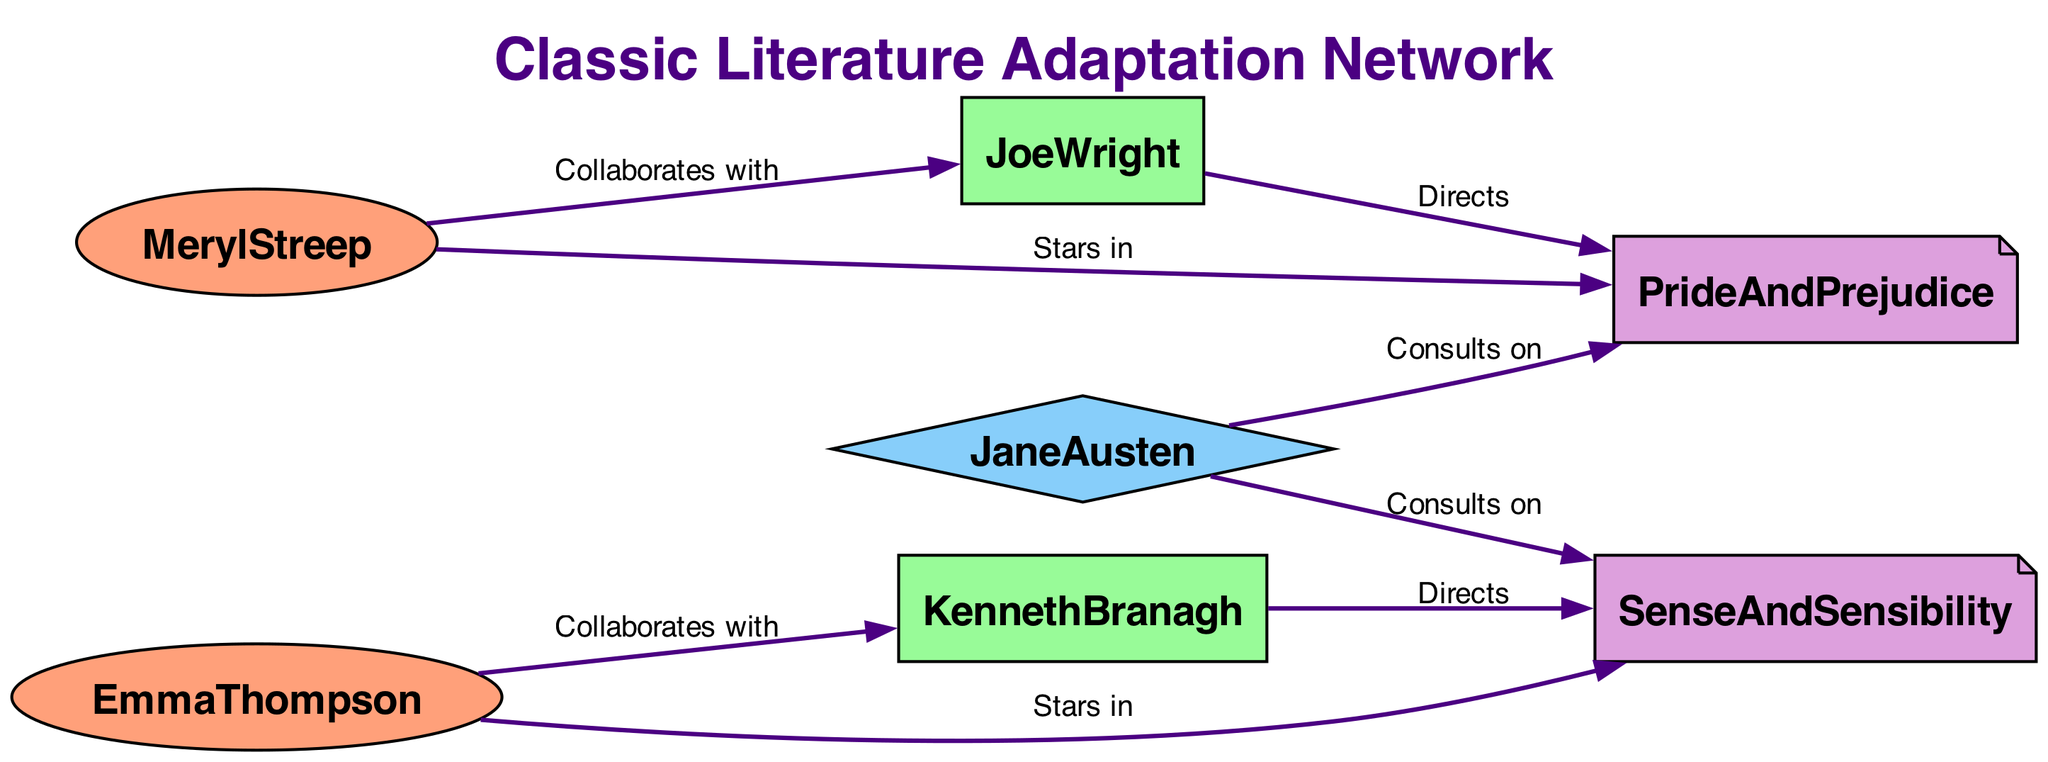What is the total number of nodes in the diagram? By counting each node listed in the data, there are 7 nodes in total: MerylStreep, JoeWright, EmmaThompson, KennethBranagh, JaneAusten, PrideAndPrejudice, and SenseAndSensibility.
Answer: 7 Who is the literary consultant for "Pride and Prejudice"? The directed edge from JaneAusten to PrideAndPrejudice indicates that JaneAusten is the consultant for this literary work.
Answer: Jane Austen Which actor collaborates with Joe Wright? The edge from MerylStreep to JoeWright shows that MerylStreep is the actor who collaborates with Joe Wright.
Answer: Meryl Streep Which two pieces of literary work does Jane Austen consult on? The two directed edges from JaneAusten indicate that she consults on both PrideAndPrejudice and SenseAndSensibility.
Answer: Pride and Prejudice, Sense and Sensibility Who directs "Sense and Sensibility"? The directed edge from KennethBranagh to SenseAndSensibility shows that Kenneth Branagh is the director of this literary work.
Answer: Kenneth Branagh What is the relationship between Emma Thompson and Kenneth Branagh? The edge labeled "Collaborates with" indicates that EmmaThompson collaborates with KennethBranagh, highlighting a professional connection.
Answer: Collaborates with How many collaborations are represented in the diagram? The edges represent collaborations: MerylStreep with JoeWright and EmmaThompson with KennethBranagh, totaling 2 collaborations.
Answer: 2 Identify the actor who stars in "Pride and Prejudice". According to the edge from MerylStreep to PrideAndPrejudice, Meryl Streep is the actor who stars in this literary work.
Answer: Meryl Streep Which director is connected to "Pride and Prejudice"? The directed edge from JoeWright to PrideAndPrejudice shows that Joe Wright is the director connected to this literary work.
Answer: Joe Wright 